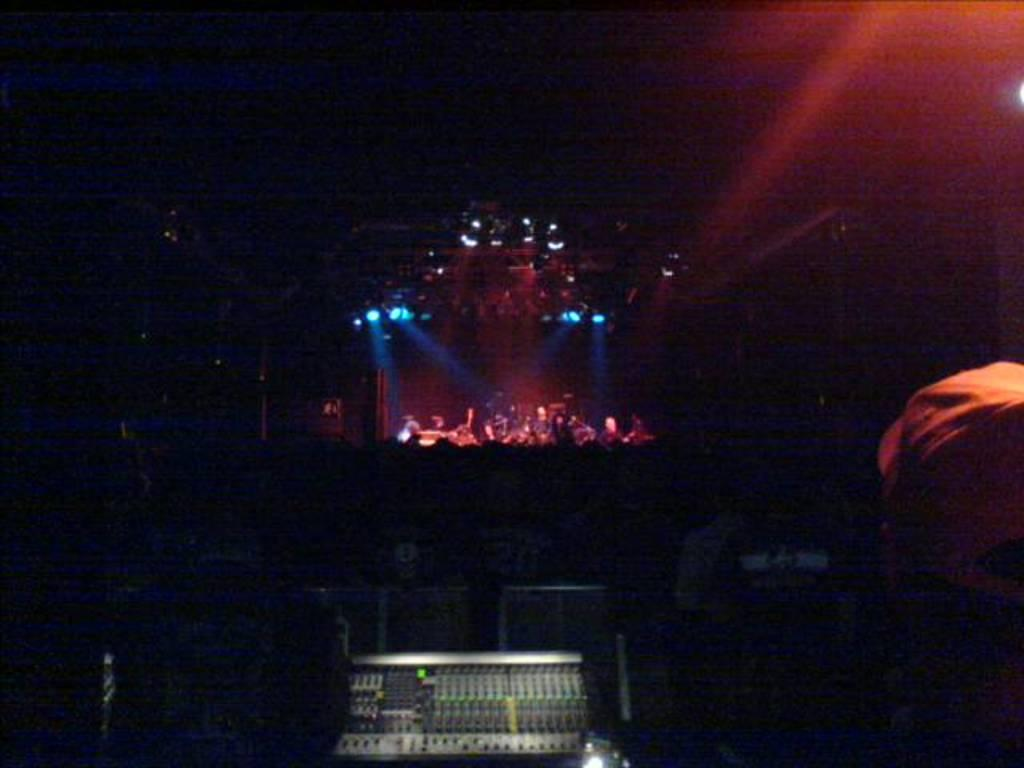What is the main feature of the image? There is a stage in the image. What can be seen on the stage? There are objects on the stage. What else is visible in the image besides the stage? There are devices visible in the image. Can you describe the person in the image? There is a person on the right side of the image. What can be seen in the image that provides illumination? There are lights in the image. How would you describe the overall lighting in the image? The background of the image is dark. Where is the toad located in the image? There is no toad present in the image. What type of liquid can be seen in the middle of the image? There is no liquid visible in the image; it primarily features a stage, objects, devices, a person, lights, and a dark background. 